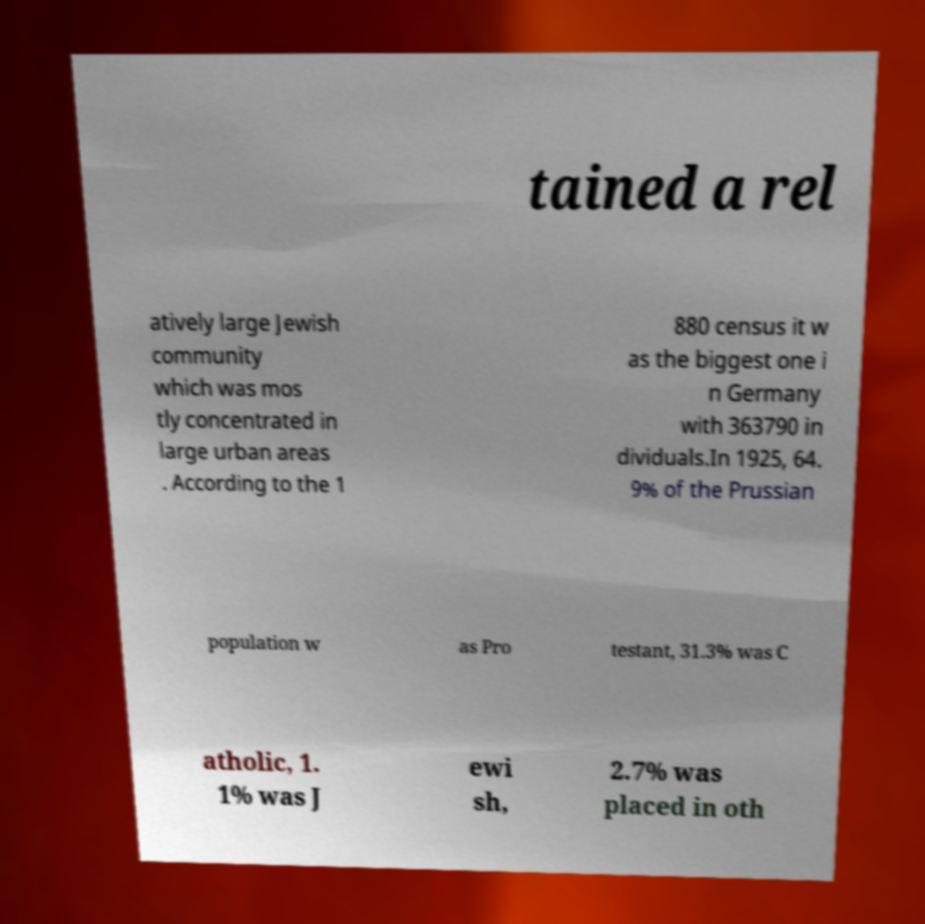I need the written content from this picture converted into text. Can you do that? tained a rel atively large Jewish community which was mos tly concentrated in large urban areas . According to the 1 880 census it w as the biggest one i n Germany with 363790 in dividuals.In 1925, 64. 9% of the Prussian population w as Pro testant, 31.3% was C atholic, 1. 1% was J ewi sh, 2.7% was placed in oth 